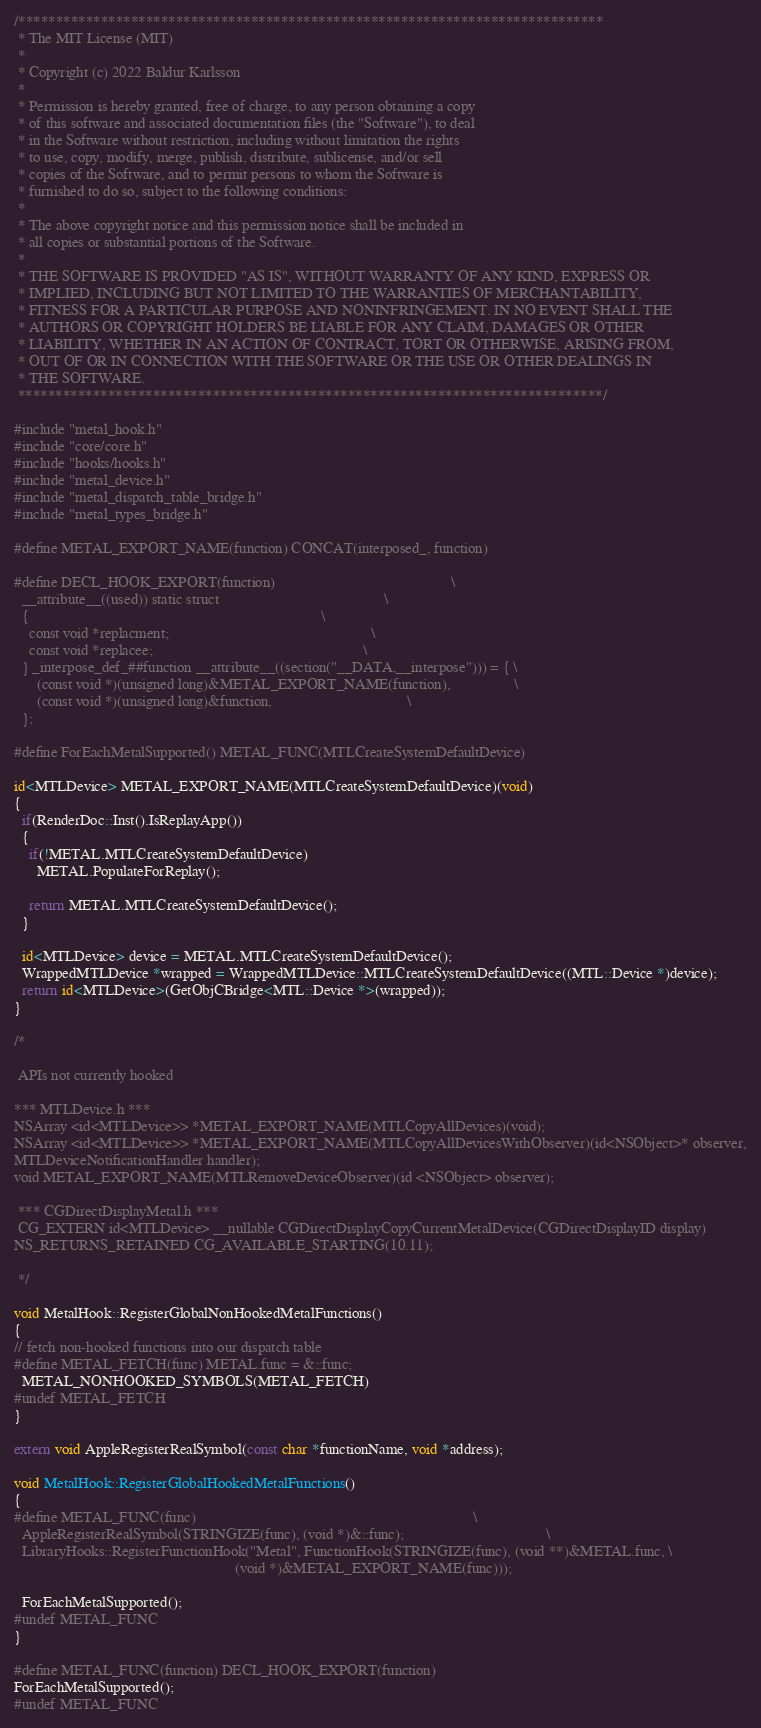Convert code to text. <code><loc_0><loc_0><loc_500><loc_500><_ObjectiveC_>/******************************************************************************
 * The MIT License (MIT)
 *
 * Copyright (c) 2022 Baldur Karlsson
 *
 * Permission is hereby granted, free of charge, to any person obtaining a copy
 * of this software and associated documentation files (the "Software"), to deal
 * in the Software without restriction, including without limitation the rights
 * to use, copy, modify, merge, publish, distribute, sublicense, and/or sell
 * copies of the Software, and to permit persons to whom the Software is
 * furnished to do so, subject to the following conditions:
 *
 * The above copyright notice and this permission notice shall be included in
 * all copies or substantial portions of the Software.
 *
 * THE SOFTWARE IS PROVIDED "AS IS", WITHOUT WARRANTY OF ANY KIND, EXPRESS OR
 * IMPLIED, INCLUDING BUT NOT LIMITED TO THE WARRANTIES OF MERCHANTABILITY,
 * FITNESS FOR A PARTICULAR PURPOSE AND NONINFRINGEMENT. IN NO EVENT SHALL THE
 * AUTHORS OR COPYRIGHT HOLDERS BE LIABLE FOR ANY CLAIM, DAMAGES OR OTHER
 * LIABILITY, WHETHER IN AN ACTION OF CONTRACT, TORT OR OTHERWISE, ARISING FROM,
 * OUT OF OR IN CONNECTION WITH THE SOFTWARE OR THE USE OR OTHER DEALINGS IN
 * THE SOFTWARE.
 ******************************************************************************/

#include "metal_hook.h"
#include "core/core.h"
#include "hooks/hooks.h"
#include "metal_device.h"
#include "metal_dispatch_table_bridge.h"
#include "metal_types_bridge.h"

#define METAL_EXPORT_NAME(function) CONCAT(interposed_, function)

#define DECL_HOOK_EXPORT(function)                                               \
  __attribute__((used)) static struct                                            \
  {                                                                              \
    const void *replacment;                                                      \
    const void *replacee;                                                        \
  } _interpose_def_##function __attribute__((section("__DATA,__interpose"))) = { \
      (const void *)(unsigned long)&METAL_EXPORT_NAME(function),                 \
      (const void *)(unsigned long)&function,                                    \
  };

#define ForEachMetalSupported() METAL_FUNC(MTLCreateSystemDefaultDevice)

id<MTLDevice> METAL_EXPORT_NAME(MTLCreateSystemDefaultDevice)(void)
{
  if(RenderDoc::Inst().IsReplayApp())
  {
    if(!METAL.MTLCreateSystemDefaultDevice)
      METAL.PopulateForReplay();

    return METAL.MTLCreateSystemDefaultDevice();
  }

  id<MTLDevice> device = METAL.MTLCreateSystemDefaultDevice();
  WrappedMTLDevice *wrapped = WrappedMTLDevice::MTLCreateSystemDefaultDevice((MTL::Device *)device);
  return id<MTLDevice>(GetObjCBridge<MTL::Device *>(wrapped));
}

/*

 APIs not currently hooked

*** MTLDevice.h ***
NSArray <id<MTLDevice>> *METAL_EXPORT_NAME(MTLCopyAllDevices)(void);
NSArray <id<MTLDevice>> *METAL_EXPORT_NAME(MTLCopyAllDevicesWithObserver)(id<NSObject>* observer,
MTLDeviceNotificationHandler handler);
void METAL_EXPORT_NAME(MTLRemoveDeviceObserver)(id <NSObject> observer);

 *** CGDirectDisplayMetal.h ***
 CG_EXTERN id<MTLDevice> __nullable CGDirectDisplayCopyCurrentMetalDevice(CGDirectDisplayID display)
NS_RETURNS_RETAINED CG_AVAILABLE_STARTING(10.11);

 */

void MetalHook::RegisterGlobalNonHookedMetalFunctions()
{
// fetch non-hooked functions into our dispatch table
#define METAL_FETCH(func) METAL.func = &::func;
  METAL_NONHOOKED_SYMBOLS(METAL_FETCH)
#undef METAL_FETCH
}

extern void AppleRegisterRealSymbol(const char *functionName, void *address);

void MetalHook::RegisterGlobalHookedMetalFunctions()
{
#define METAL_FUNC(func)                                                                          \
  AppleRegisterRealSymbol(STRINGIZE(func), (void *)&::func);                                      \
  LibraryHooks::RegisterFunctionHook("Metal", FunctionHook(STRINGIZE(func), (void **)&METAL.func, \
                                                           (void *)&METAL_EXPORT_NAME(func)));

  ForEachMetalSupported();
#undef METAL_FUNC
}

#define METAL_FUNC(function) DECL_HOOK_EXPORT(function)
ForEachMetalSupported();
#undef METAL_FUNC
</code> 